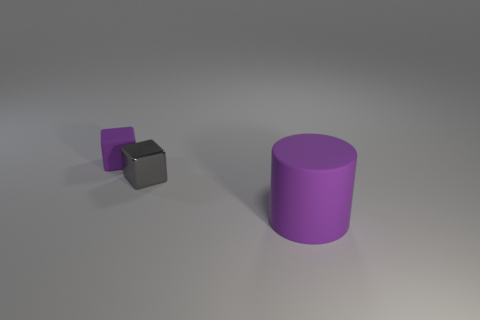How many objects are cyan balls or purple objects behind the matte cylinder?
Give a very brief answer. 1. Is the number of purple matte objects that are in front of the big matte cylinder greater than the number of matte cubes?
Provide a short and direct response. No. Is the number of large rubber cylinders that are behind the small gray metal thing the same as the number of big objects to the left of the big purple cylinder?
Your answer should be very brief. Yes. Are there any tiny metal objects to the left of the rubber thing that is to the left of the purple cylinder?
Your answer should be compact. No. What is the shape of the large object?
Provide a succinct answer. Cylinder. What size is the rubber cylinder that is the same color as the tiny rubber thing?
Your answer should be very brief. Large. There is a cube in front of the tiny block that is on the left side of the gray metal thing; what size is it?
Provide a succinct answer. Small. What size is the purple thing left of the big purple matte thing?
Provide a succinct answer. Small. Are there fewer gray things that are right of the small purple block than tiny gray shiny objects in front of the large cylinder?
Provide a short and direct response. No. What is the color of the rubber cylinder?
Keep it short and to the point. Purple. 